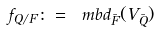Convert formula to latex. <formula><loc_0><loc_0><loc_500><loc_500>f _ { Q / F } \colon = \ m b d _ { \bar { F } } ( V _ { \bar { Q } } )</formula> 